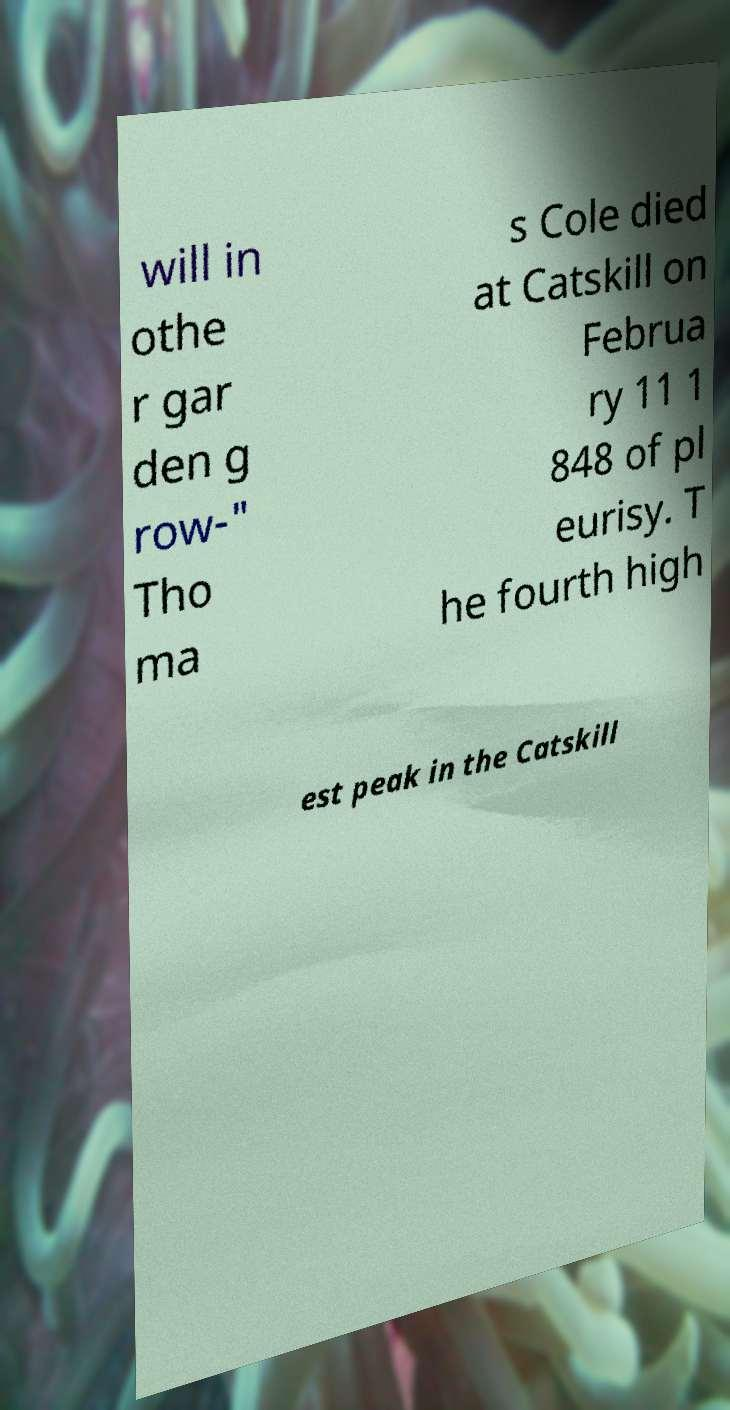Could you extract and type out the text from this image? will in othe r gar den g row-" Tho ma s Cole died at Catskill on Februa ry 11 1 848 of pl eurisy. T he fourth high est peak in the Catskill 